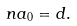<formula> <loc_0><loc_0><loc_500><loc_500>\ n a _ { 0 } = d .</formula> 